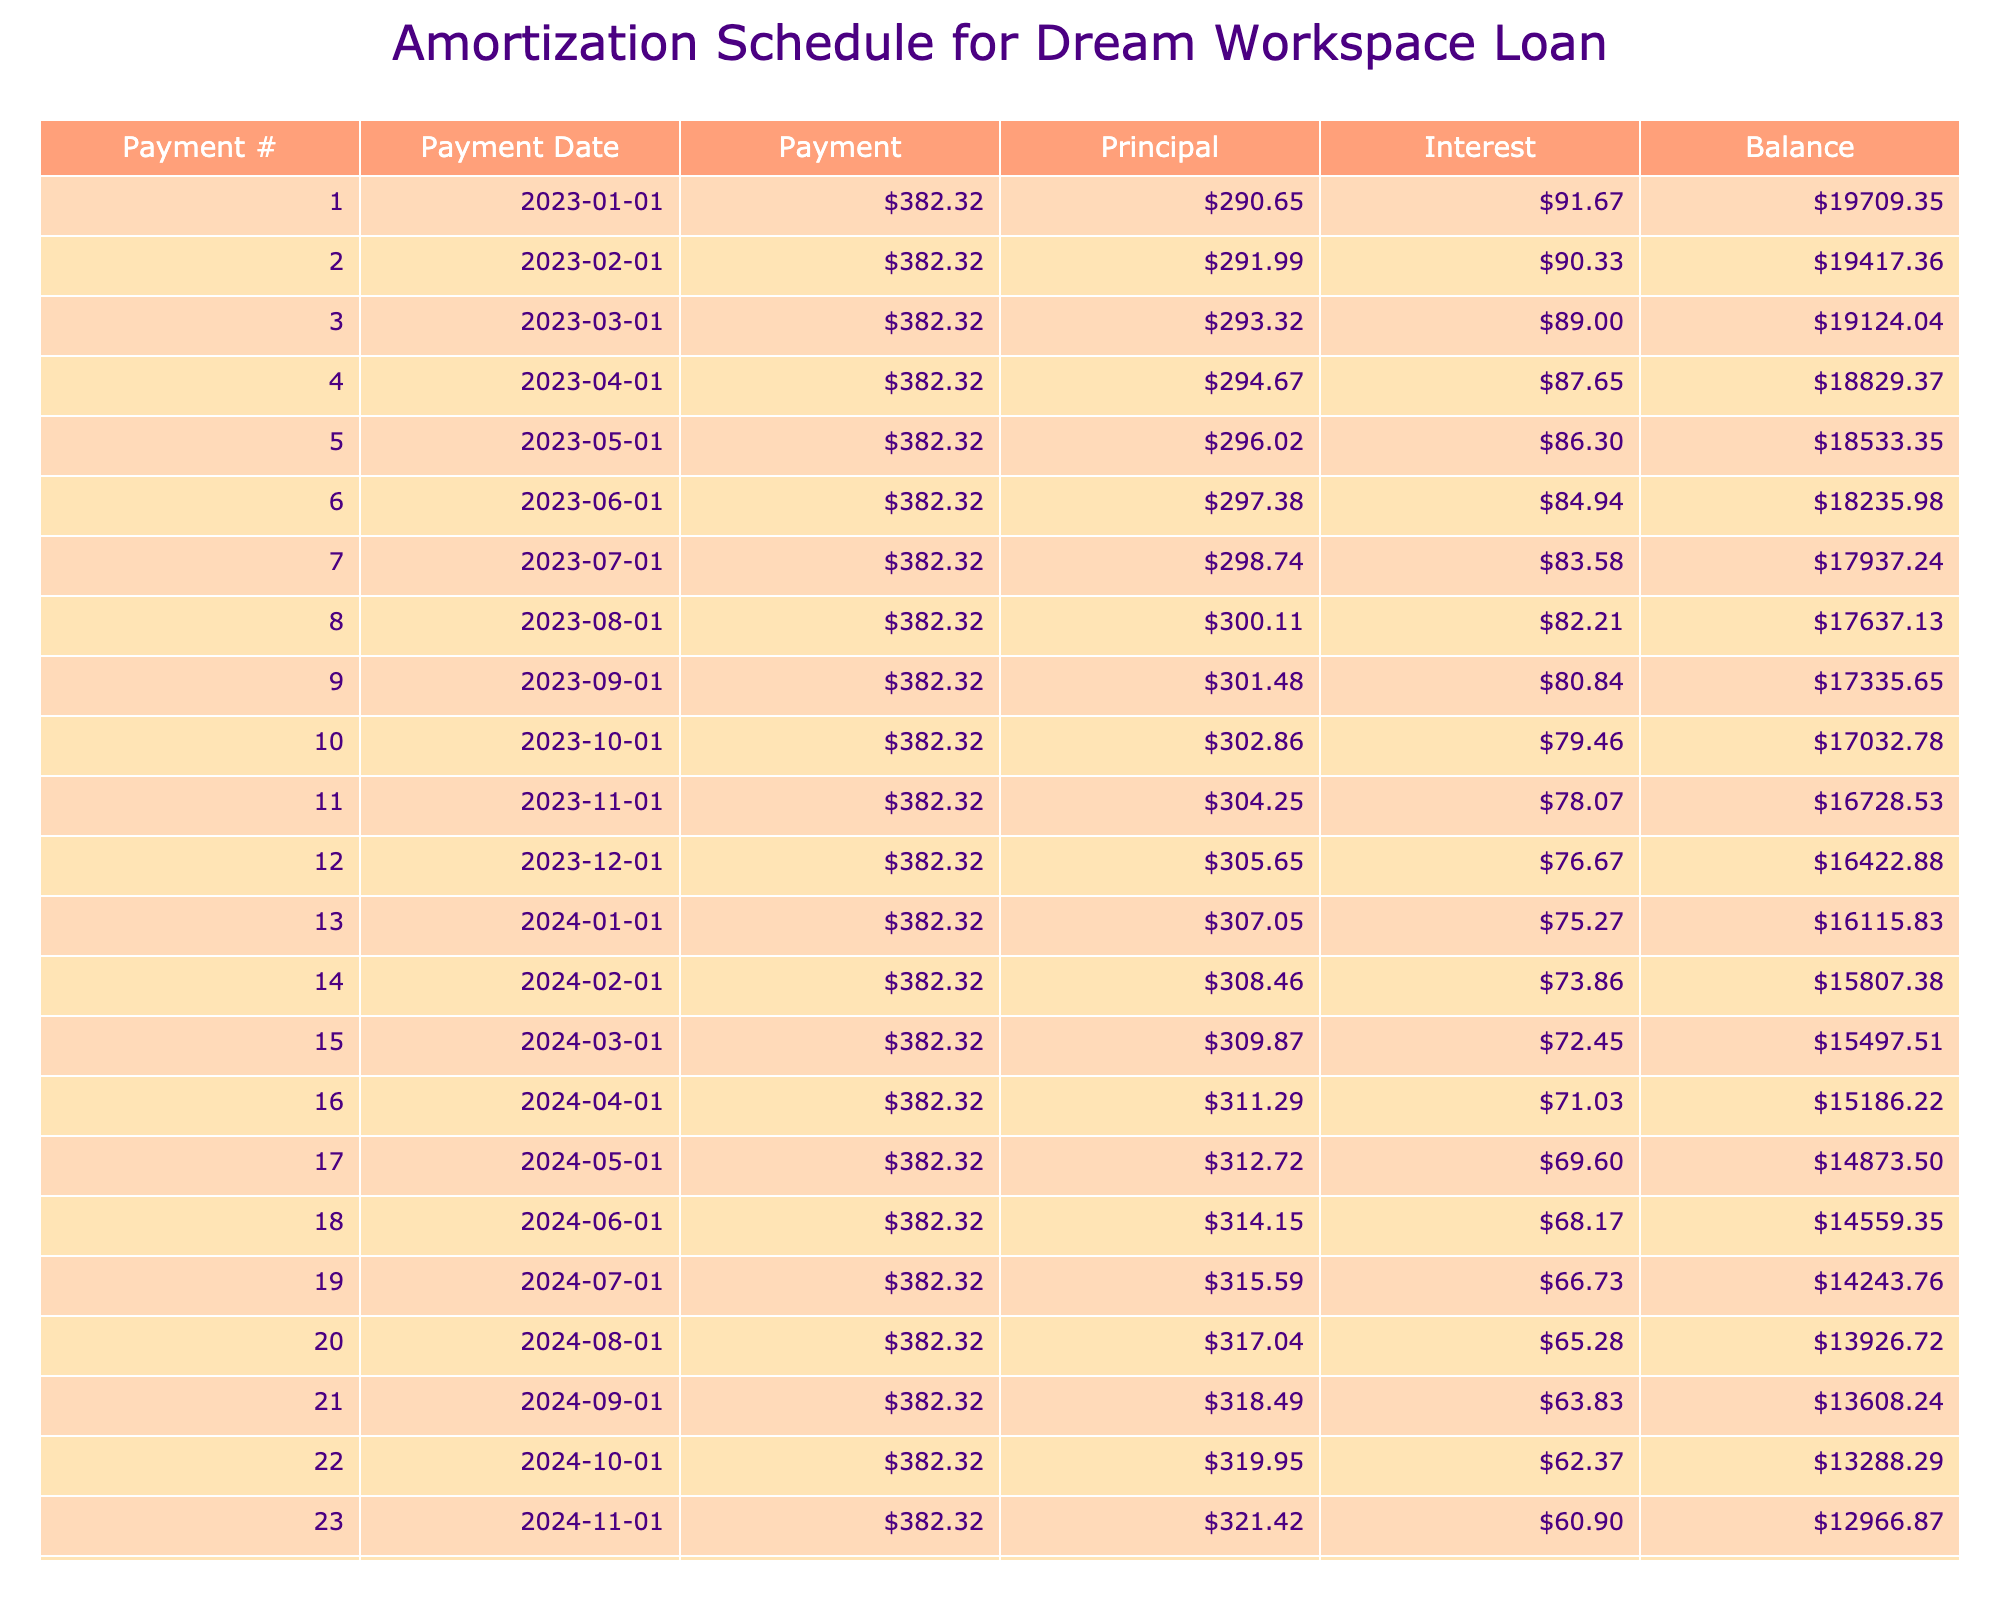What is the total amount paid over the life of the loan? The total amount paid can be found in the table under the "Total Payment" column. It shows that the total payment is $22,939.20.
Answer: 22,939.20 What is the monthly payment for the loan? The monthly payment is listed under the "Monthly Payment" column, which indicates it is $382.32.
Answer: 382.32 What is the total interest paid on this loan? The total interest paid over the life of the loan is shown in the "Total Interest" column. According to the table, it is $3,939.20.
Answer: 3,939.20 Did the monthly payment exceed the principal payment in the first month? To determine this, we look at the first month's values in the "Payment" and "Principal" columns. The total monthly payment is $382.32, while the principal payment will be calculated as monthly payment - interest payment. After calculation, the principal payment in the first month is lower than the monthly payment.
Answer: Yes What is the principal payment amount in the last month? In the last month of the loan, which is the 60th payment, the table lists the principal payment amount. The data needs to check the values in the last row for principal, which leads to the principal payment for the 60th month being $370.87.
Answer: 370.87 How much interest do we pay in the first month? The first month's interest can be calculated using the loan balance multiplied by the monthly interest rate. The loan balance is $20,000 and the monthly interest rate can be calculated from the annual rate. Therefore, the interest for the first month is $91.67.
Answer: 91.67 What is the balance remaining after the third payment? To find the balance after the third payment, we need to subtract the principal payments for the first three months from the initial loan amount. This involves summing the principal payments for those months and subtracting from $20,000. The balance is $18,118.11 after the third payment.
Answer: 18,118.11 Which payment has the highest interest payment amount? Typically, the earliest payments have the highest interest due to the higher initial principal. We check the interest column to verify the values for the first few payments. The first payment has the highest interest payment of $91.67.
Answer: 91.67 What is the difference between total payment and total interest? This difference can be found by subtracting the total interest from the total payment. The calculation shows that total payment minus total interest equals $22,939.20 - $3,939.20 = $19,000.00, representing the total principal paid.
Answer: 19,000.00 